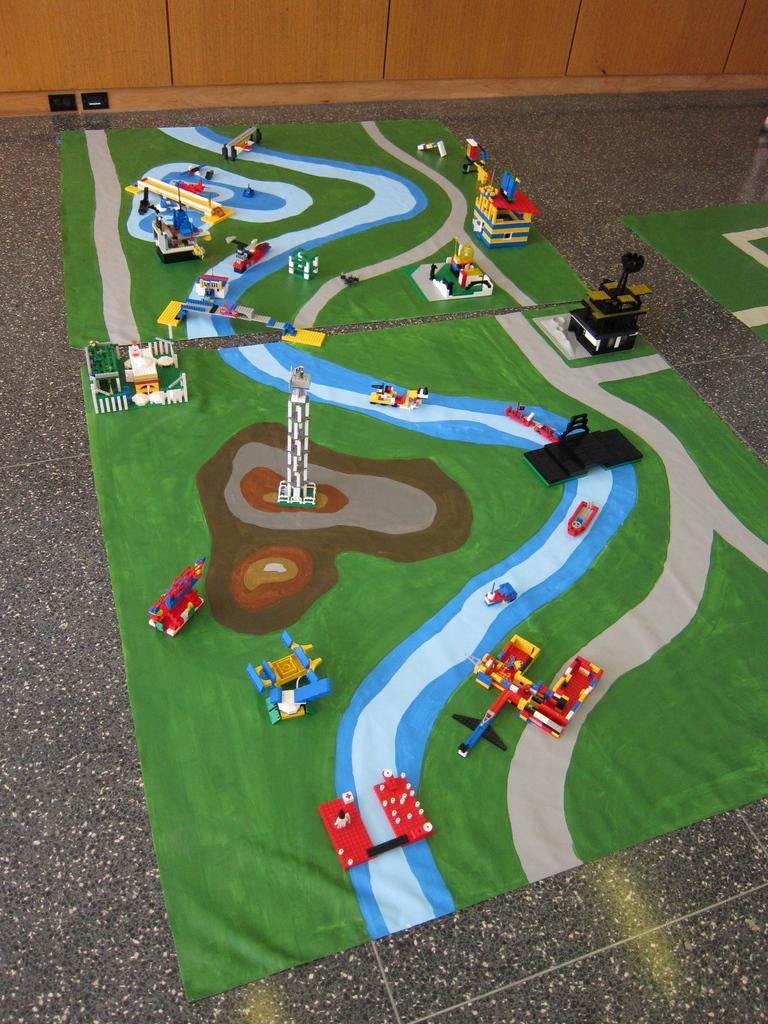What is on the floor in the image? There are mats on the floor. What is placed on the mats? There are toys on the mats. Can you describe the objects on the top side of the image? It appears there are cupboards at the top side. What type of mind-reading abilities can be seen in the image? There are no mind-reading abilities or related objects present in the image. Can you describe the haircut of the toys in the image? The toys in the image do not have hair, so there is no haircut to describe. 